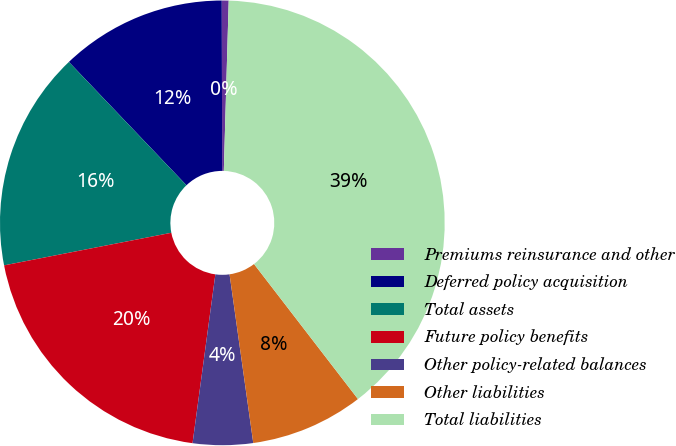<chart> <loc_0><loc_0><loc_500><loc_500><pie_chart><fcel>Premiums reinsurance and other<fcel>Deferred policy acquisition<fcel>Total assets<fcel>Future policy benefits<fcel>Other policy-related balances<fcel>Other liabilities<fcel>Total liabilities<nl><fcel>0.5%<fcel>12.08%<fcel>15.94%<fcel>19.8%<fcel>4.36%<fcel>8.22%<fcel>39.1%<nl></chart> 